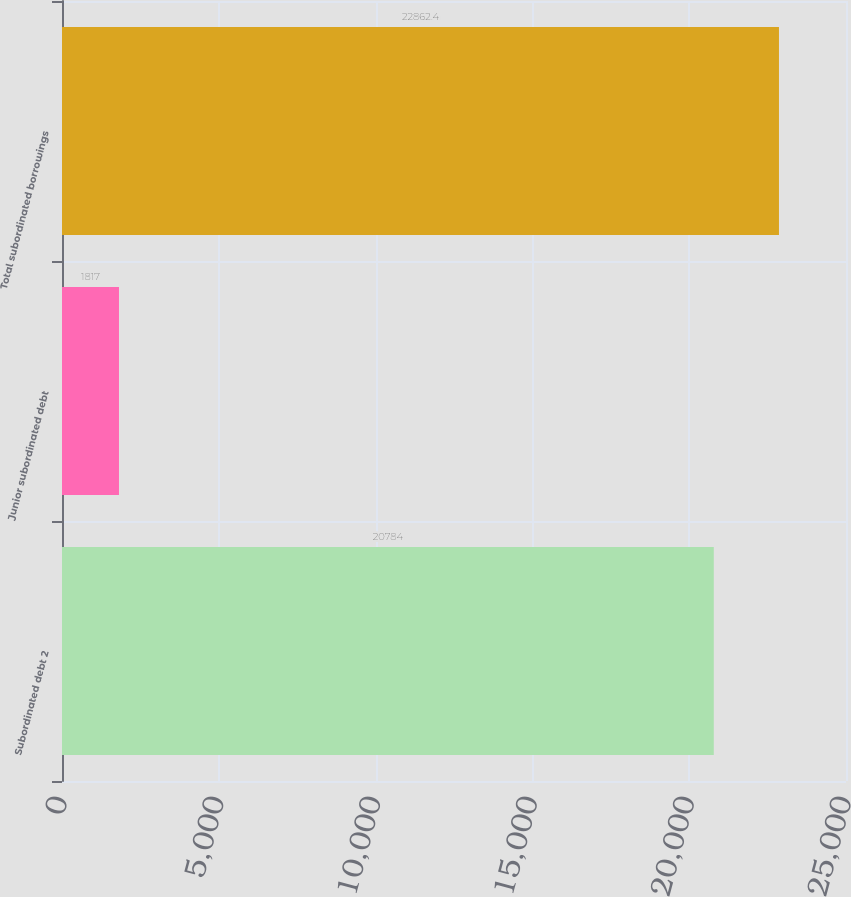<chart> <loc_0><loc_0><loc_500><loc_500><bar_chart><fcel>Subordinated debt 2<fcel>Junior subordinated debt<fcel>Total subordinated borrowings<nl><fcel>20784<fcel>1817<fcel>22862.4<nl></chart> 